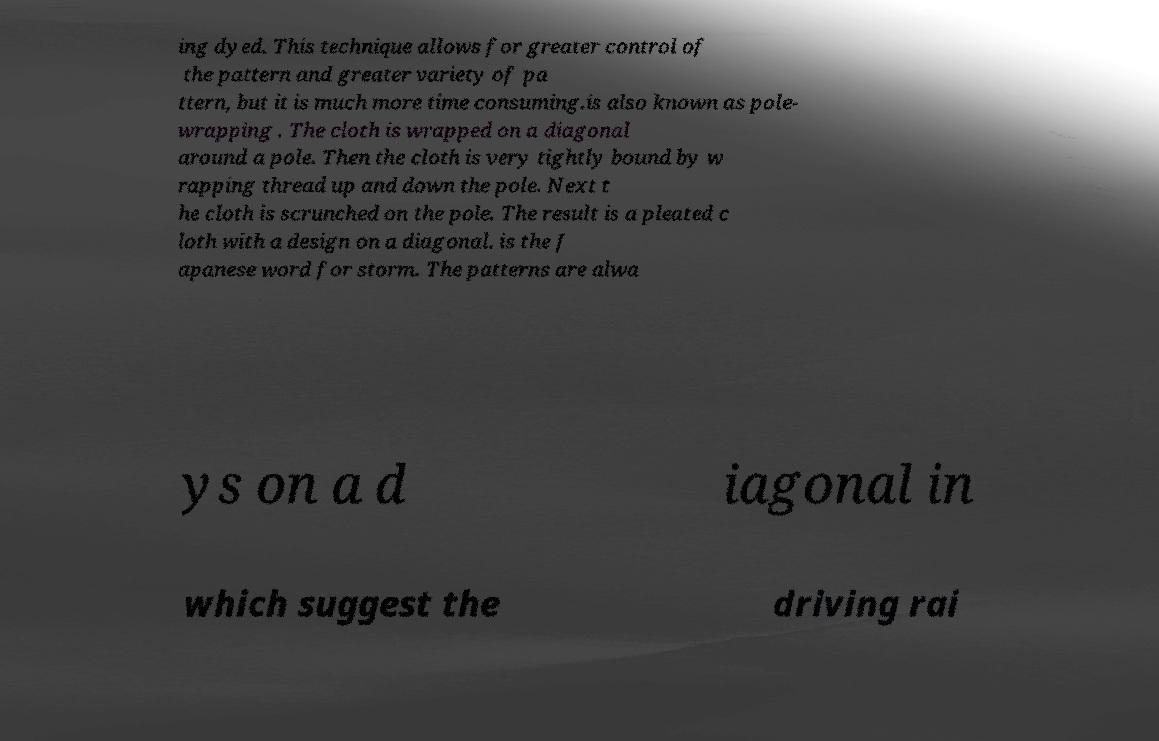Please read and relay the text visible in this image. What does it say? ing dyed. This technique allows for greater control of the pattern and greater variety of pa ttern, but it is much more time consuming.is also known as pole- wrapping . The cloth is wrapped on a diagonal around a pole. Then the cloth is very tightly bound by w rapping thread up and down the pole. Next t he cloth is scrunched on the pole. The result is a pleated c loth with a design on a diagonal. is the J apanese word for storm. The patterns are alwa ys on a d iagonal in which suggest the driving rai 